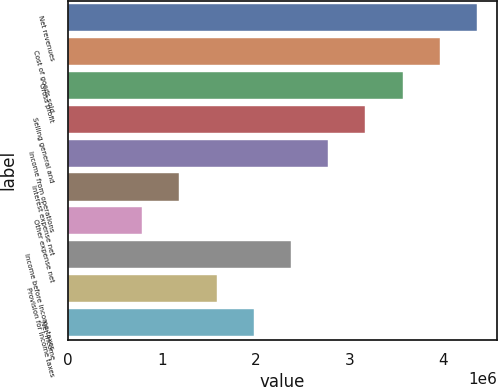Convert chart. <chart><loc_0><loc_0><loc_500><loc_500><bar_chart><fcel>Net revenues<fcel>Cost of goods sold<fcel>Gross profit<fcel>Selling general and<fcel>Income from operations<fcel>Interest expense net<fcel>Other expense net<fcel>Income before income taxes<fcel>Provision for income taxes<fcel>Net income<nl><fcel>4.35964e+06<fcel>3.96331e+06<fcel>3.56698e+06<fcel>3.17065e+06<fcel>2.77432e+06<fcel>1.18899e+06<fcel>792663<fcel>2.37799e+06<fcel>1.58533e+06<fcel>1.98166e+06<nl></chart> 